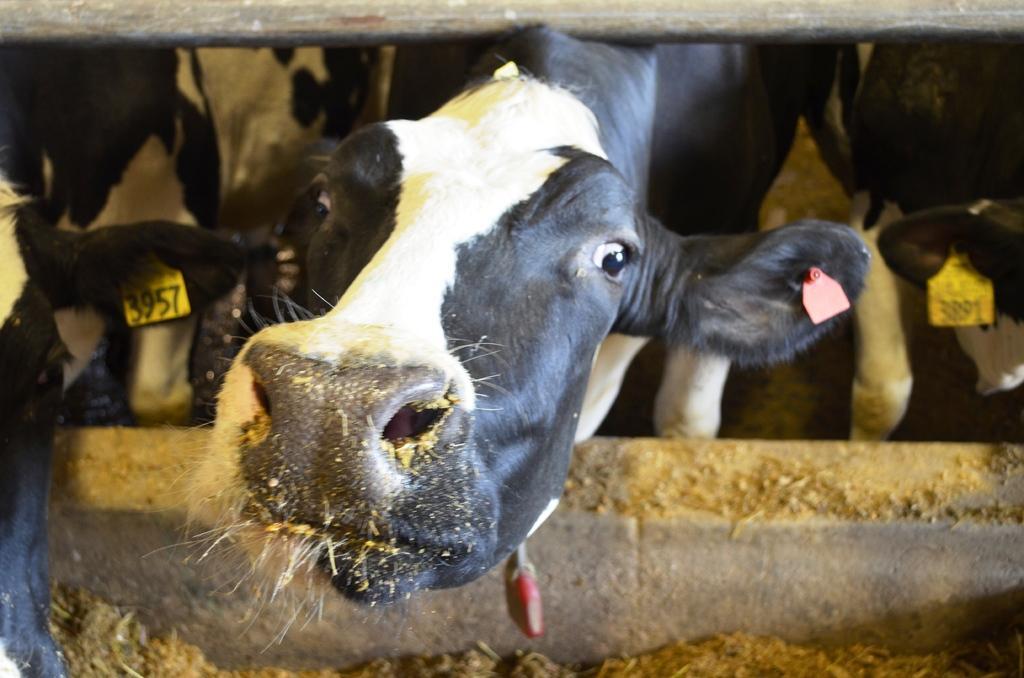Describe this image in one or two sentences. In this picture I can see some animals with tags on which I can see some numbers. 